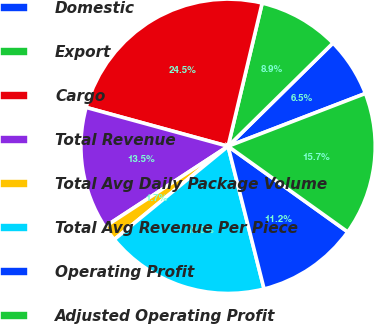<chart> <loc_0><loc_0><loc_500><loc_500><pie_chart><fcel>Domestic<fcel>Export<fcel>Cargo<fcel>Total Revenue<fcel>Total Avg Daily Package Volume<fcel>Total Avg Revenue Per Piece<fcel>Operating Profit<fcel>Adjusted Operating Profit<nl><fcel>6.53%<fcel>8.91%<fcel>24.47%<fcel>13.46%<fcel>1.72%<fcel>18.01%<fcel>11.18%<fcel>15.73%<nl></chart> 